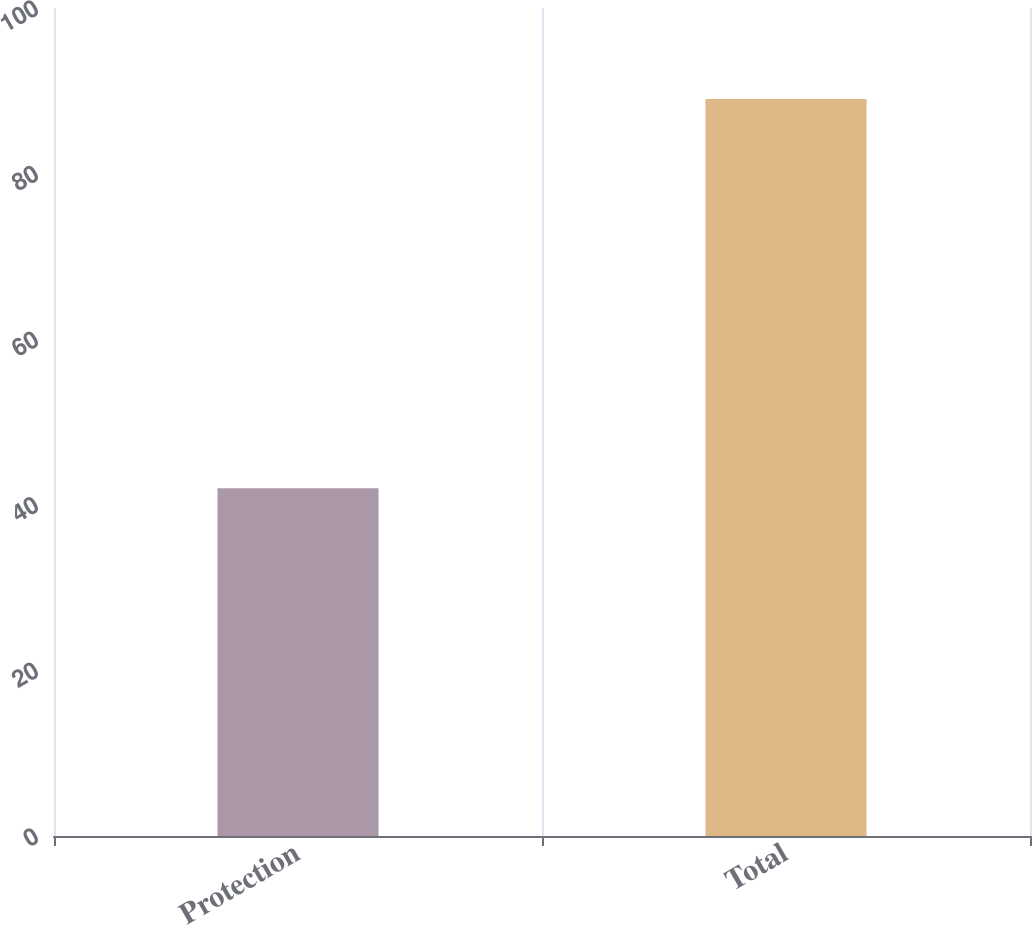Convert chart to OTSL. <chart><loc_0><loc_0><loc_500><loc_500><bar_chart><fcel>Protection<fcel>Total<nl><fcel>42<fcel>89<nl></chart> 